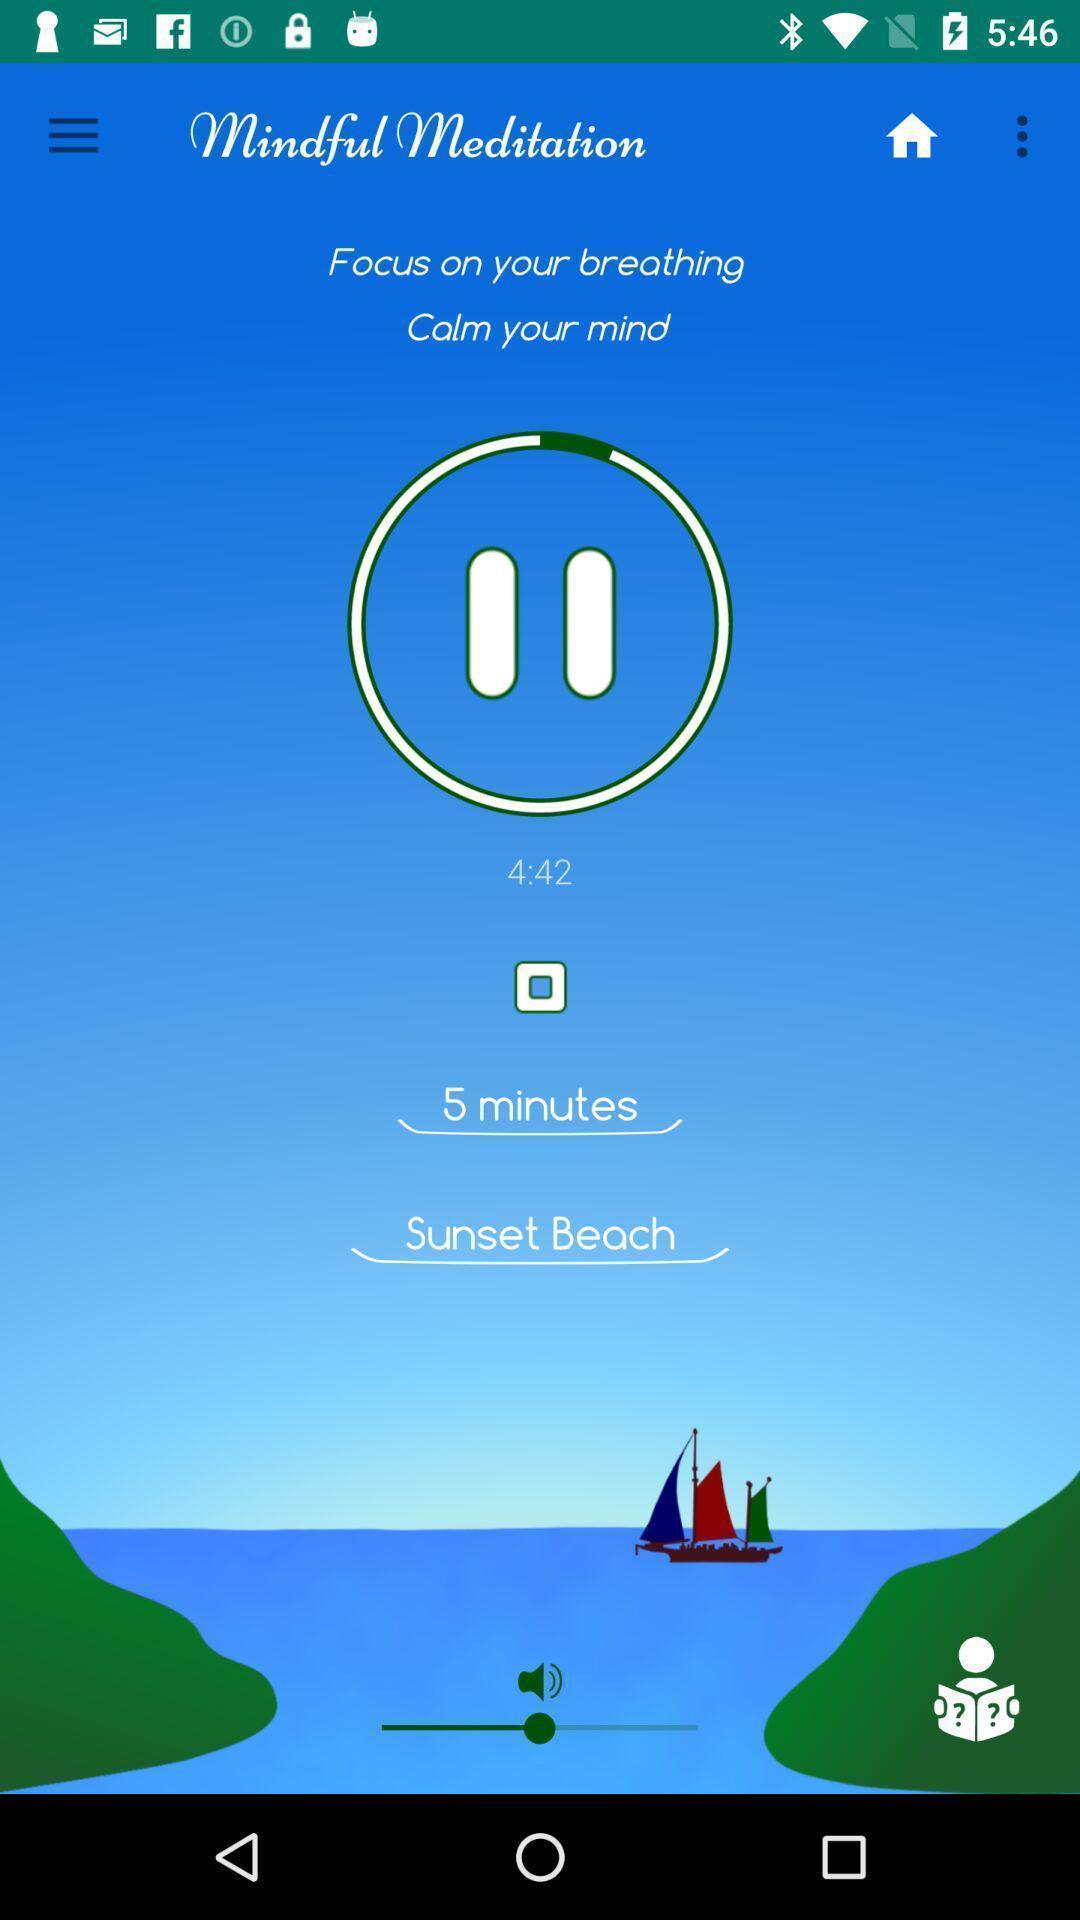Provide a detailed account of this screenshot. Screen shows a meditation app. 